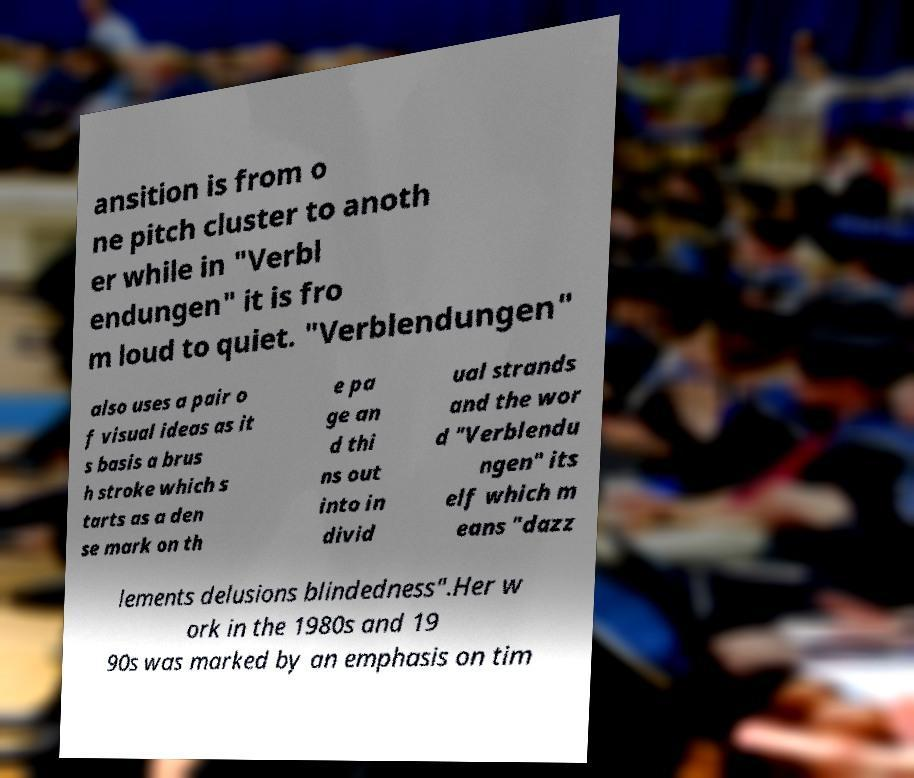Could you assist in decoding the text presented in this image and type it out clearly? ansition is from o ne pitch cluster to anoth er while in "Verbl endungen" it is fro m loud to quiet. "Verblendungen" also uses a pair o f visual ideas as it s basis a brus h stroke which s tarts as a den se mark on th e pa ge an d thi ns out into in divid ual strands and the wor d "Verblendu ngen" its elf which m eans "dazz lements delusions blindedness".Her w ork in the 1980s and 19 90s was marked by an emphasis on tim 